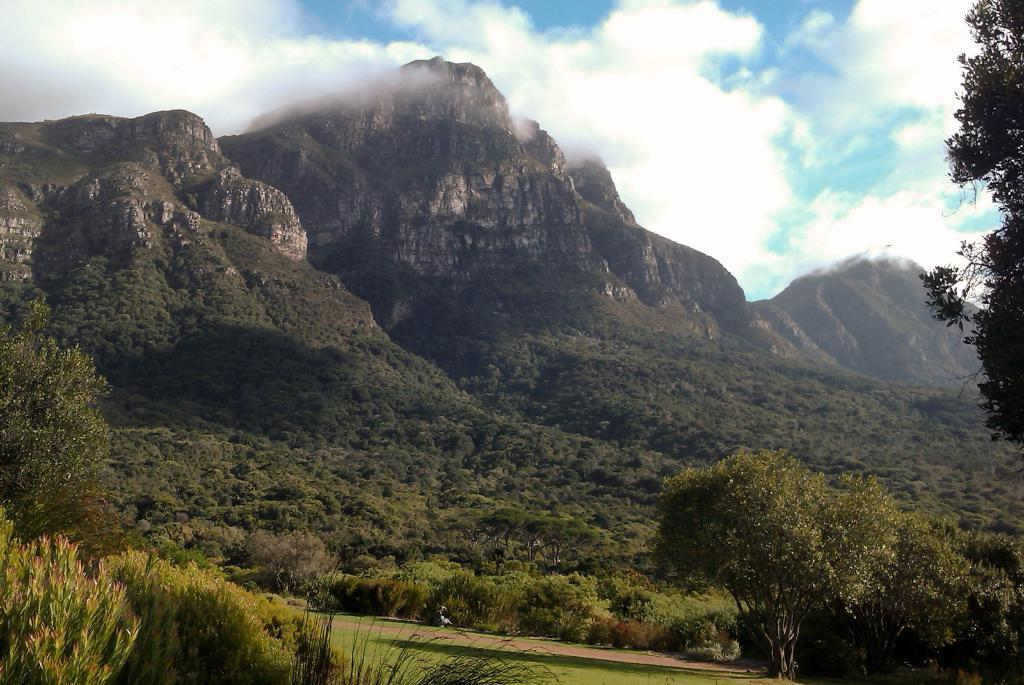What is the main feature in the center of the image? There are mountains in the center of the image. What type of vegetation can be seen in the image? Trees are present in the image. What is visible at the bottom of the image? There is ground visible at the bottom of the image, and some plants are present there as well. What can be seen in the sky at the top of the image? Clouds are present in the sky at the top of the image. What is the name of the person wearing a shirt in the image? There is no person wearing a shirt in the image; it primarily features mountains, trees, ground, plants, and clouds. 